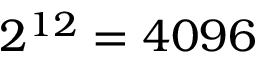<formula> <loc_0><loc_0><loc_500><loc_500>2 ^ { 1 2 } = 4 0 9 6</formula> 